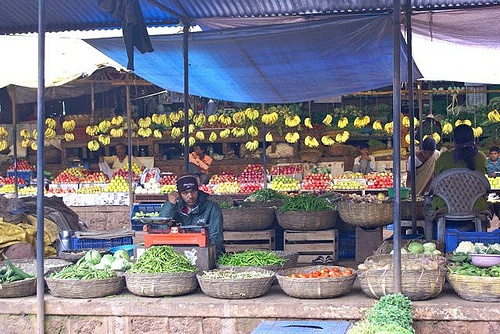Describe the objects in this image and their specific colors. I can see banana in gray, khaki, black, and tan tones, people in gray, navy, and blue tones, chair in gray and black tones, people in gray, black, navy, and darkgreen tones, and people in gray, black, navy, and purple tones in this image. 